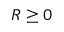<formula> <loc_0><loc_0><loc_500><loc_500>R \geq 0</formula> 